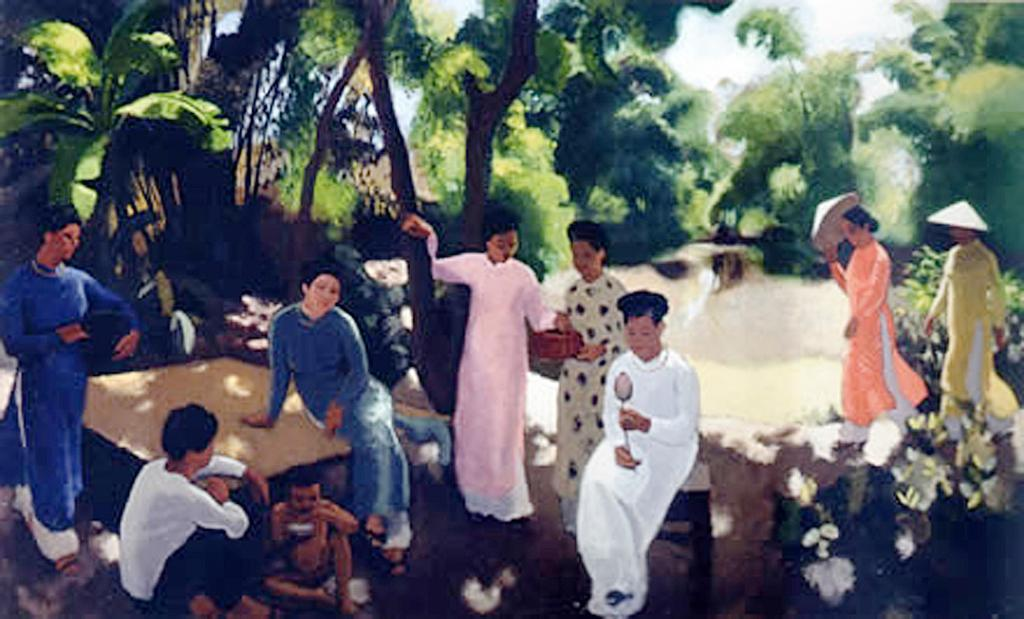What is the main subject of the image? There is a painting in the image. What are the people in the painting doing? Some people in the painting are sitting, standing, and walking. What furniture is present in the painting? There is a table and a stool in the painting. What type of natural elements are depicted in the painting? Trees, flowers, and plants are present in the painting. Where is the mailbox located in the painting? There is no mailbox present in the painting. What type of legal advice is being given in the painting? There is no lawyer or legal advice depicted in the painting; it features people sitting, standing, and walking, along with furniture and natural elements. 